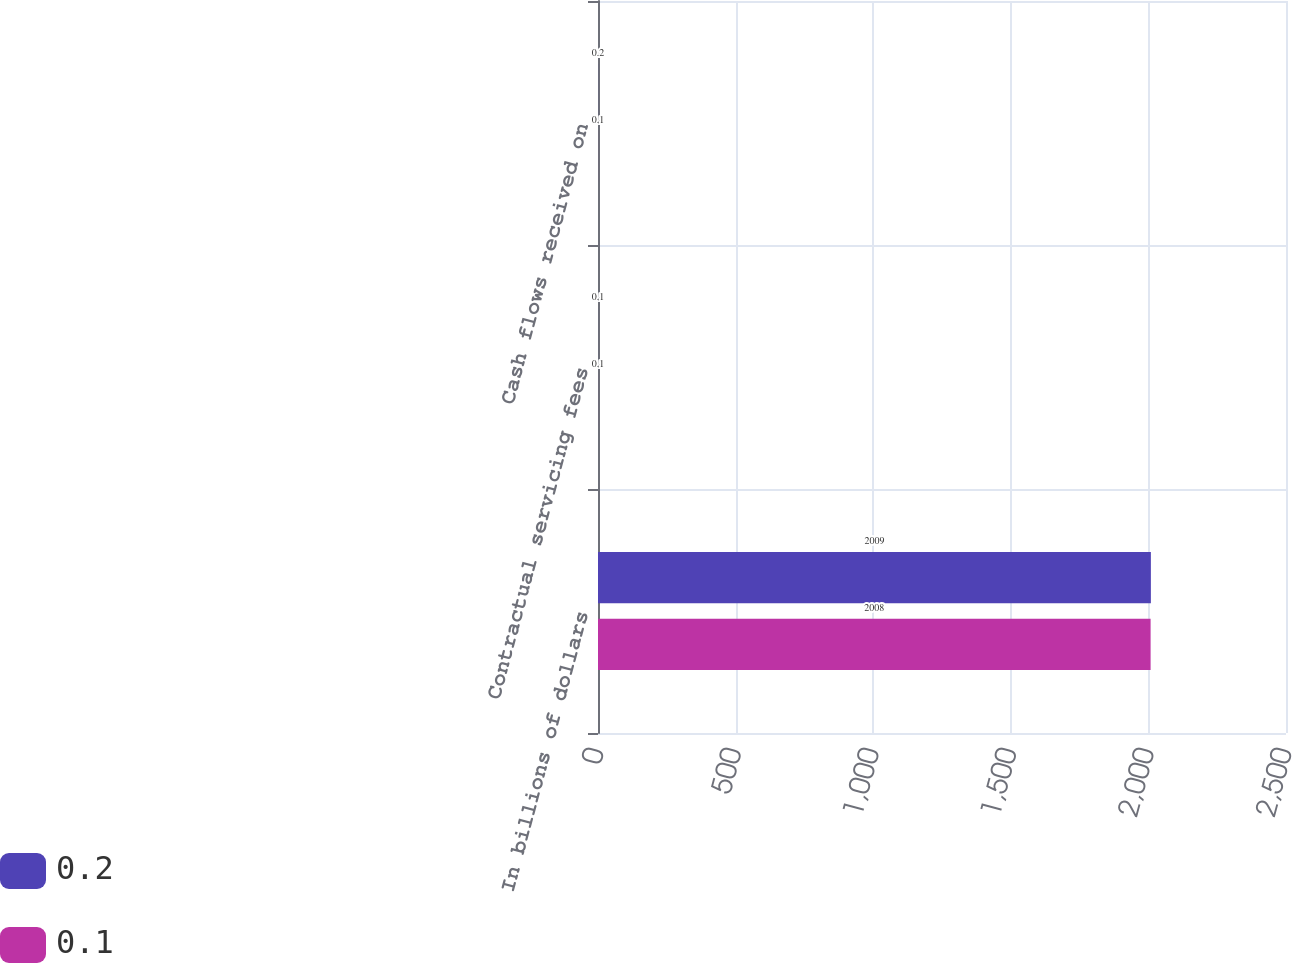<chart> <loc_0><loc_0><loc_500><loc_500><stacked_bar_chart><ecel><fcel>In billions of dollars<fcel>Contractual servicing fees<fcel>Cash flows received on<nl><fcel>0.2<fcel>2009<fcel>0.1<fcel>0.2<nl><fcel>0.1<fcel>2008<fcel>0.1<fcel>0.1<nl></chart> 